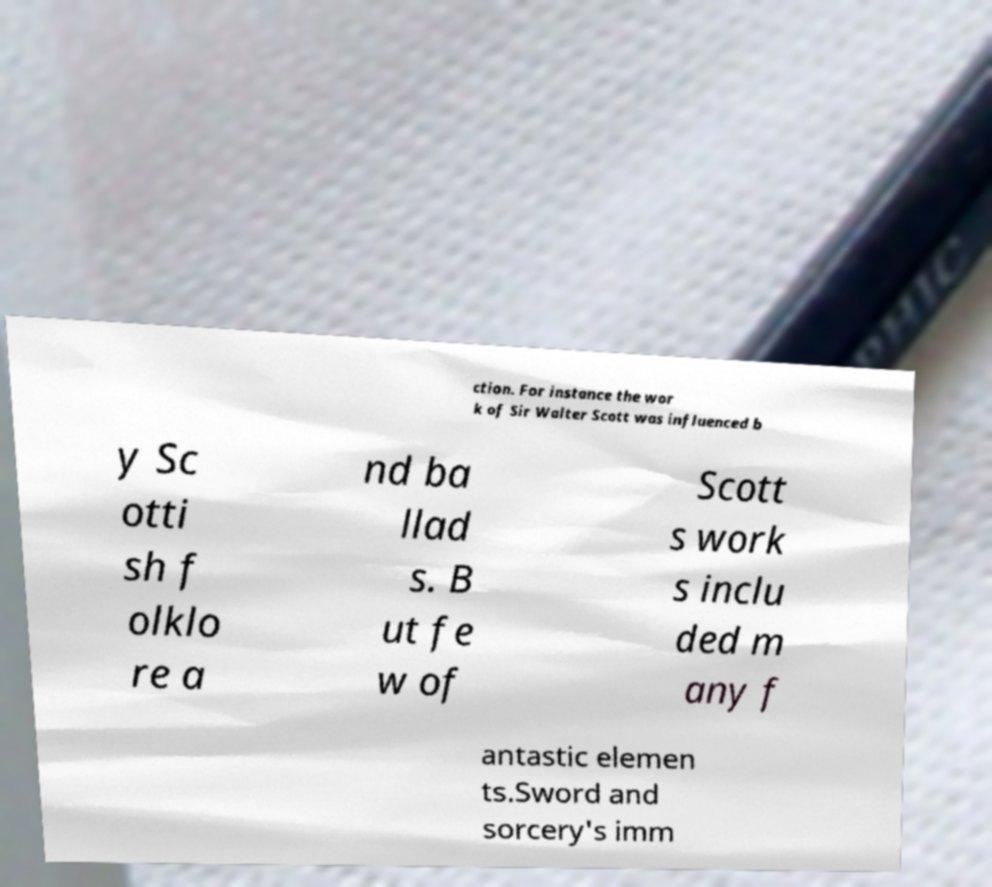What messages or text are displayed in this image? I need them in a readable, typed format. ction. For instance the wor k of Sir Walter Scott was influenced b y Sc otti sh f olklo re a nd ba llad s. B ut fe w of Scott s work s inclu ded m any f antastic elemen ts.Sword and sorcery's imm 